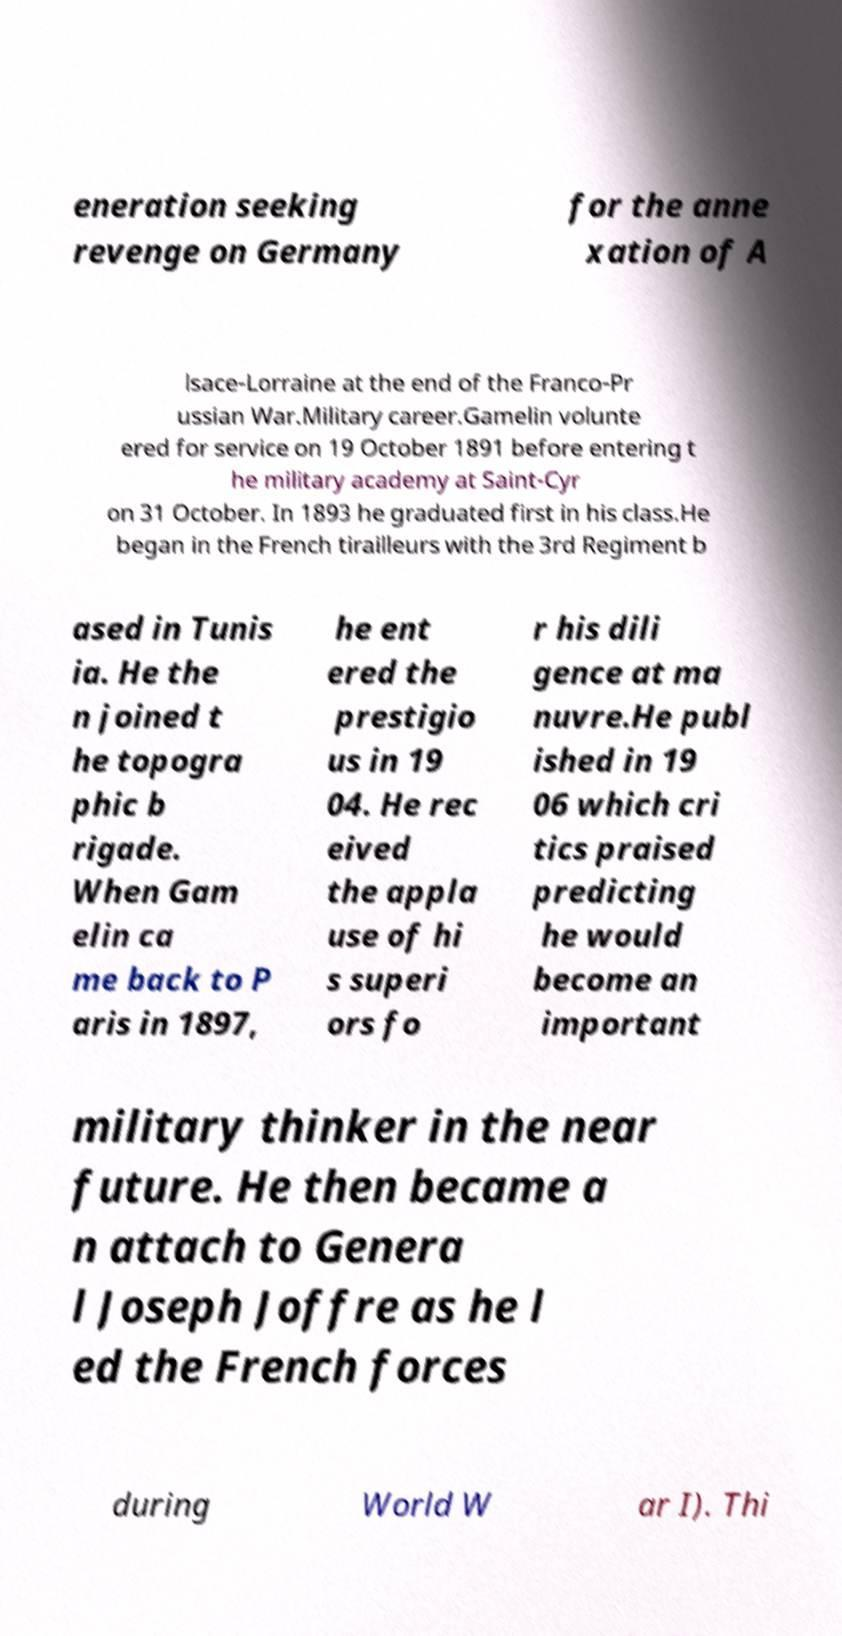Please identify and transcribe the text found in this image. eneration seeking revenge on Germany for the anne xation of A lsace-Lorraine at the end of the Franco-Pr ussian War.Military career.Gamelin volunte ered for service on 19 October 1891 before entering t he military academy at Saint-Cyr on 31 October. In 1893 he graduated first in his class.He began in the French tirailleurs with the 3rd Regiment b ased in Tunis ia. He the n joined t he topogra phic b rigade. When Gam elin ca me back to P aris in 1897, he ent ered the prestigio us in 19 04. He rec eived the appla use of hi s superi ors fo r his dili gence at ma nuvre.He publ ished in 19 06 which cri tics praised predicting he would become an important military thinker in the near future. He then became a n attach to Genera l Joseph Joffre as he l ed the French forces during World W ar I). Thi 